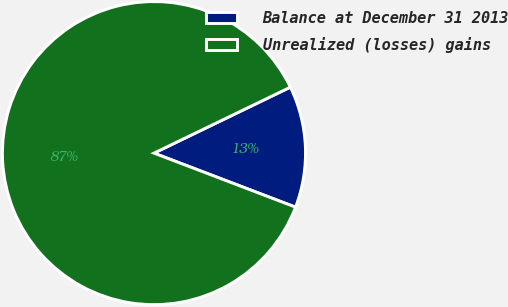Convert chart to OTSL. <chart><loc_0><loc_0><loc_500><loc_500><pie_chart><fcel>Balance at December 31 2013<fcel>Unrealized (losses) gains<nl><fcel>12.97%<fcel>87.03%<nl></chart> 